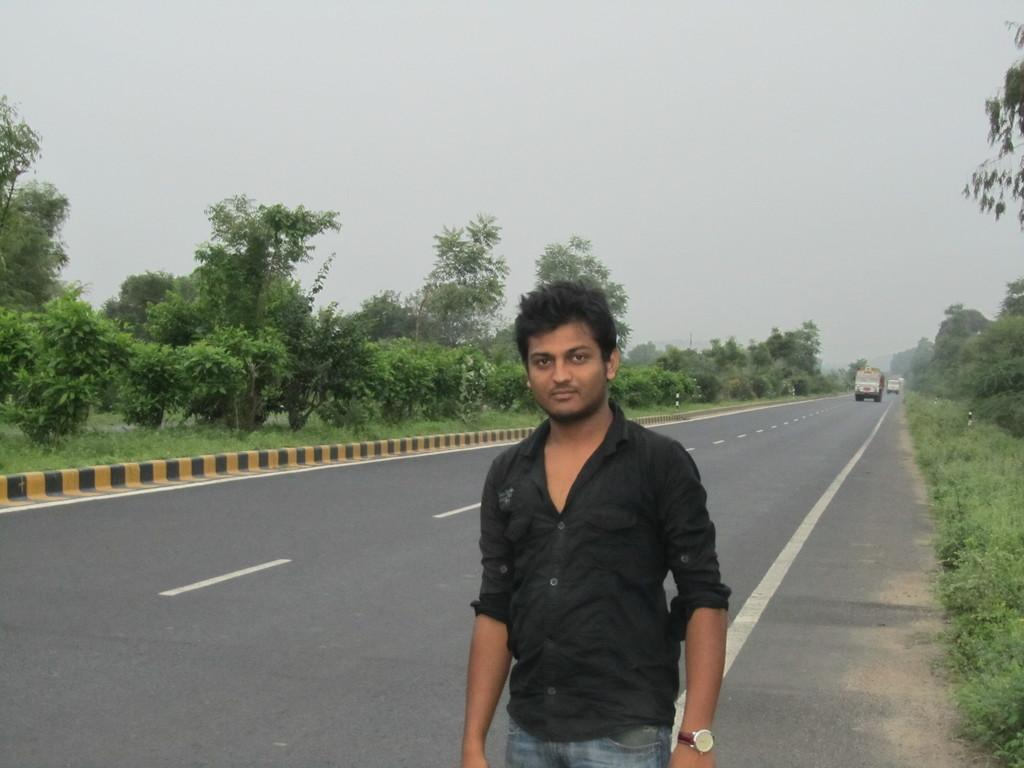What is the main subject in the foreground of the image? There is a man standing in the foreground of the image. What is the man wearing in the image? The man is wearing a black shirt in the image. What can be seen on the road in the image? There are vehicles moving on the road in the image. What type of vegetation is present on the sides of the road in the image? Trees are present on the sides of the road in the image. What is the condition of the sky in the image? The sky is clear in the image. How much thread is used to sew the man's shirt in the image? There is no information about the shirt's construction or the amount of thread used in the image. How many feet are visible on the man's shoes in the image? The image does not show the man's shoes, so it is impossible to determine the number of feet visible. 